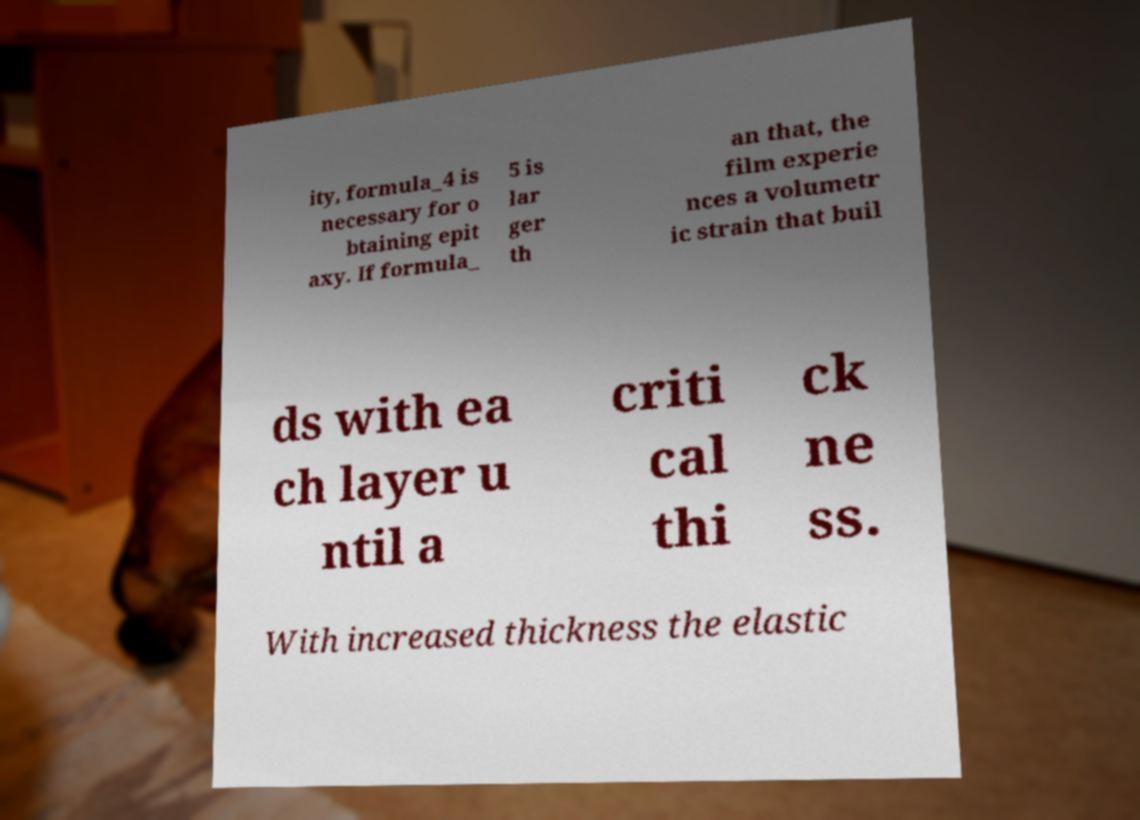I need the written content from this picture converted into text. Can you do that? ity, formula_4 is necessary for o btaining epit axy. If formula_ 5 is lar ger th an that, the film experie nces a volumetr ic strain that buil ds with ea ch layer u ntil a criti cal thi ck ne ss. With increased thickness the elastic 